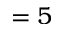Convert formula to latex. <formula><loc_0><loc_0><loc_500><loc_500>= 5</formula> 